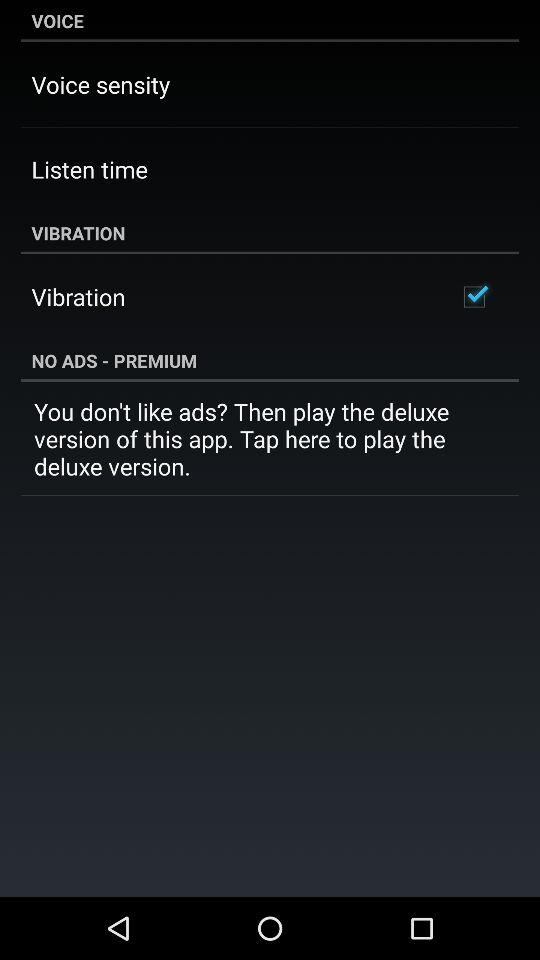What is the checked option? The checked option is "Vibration". 